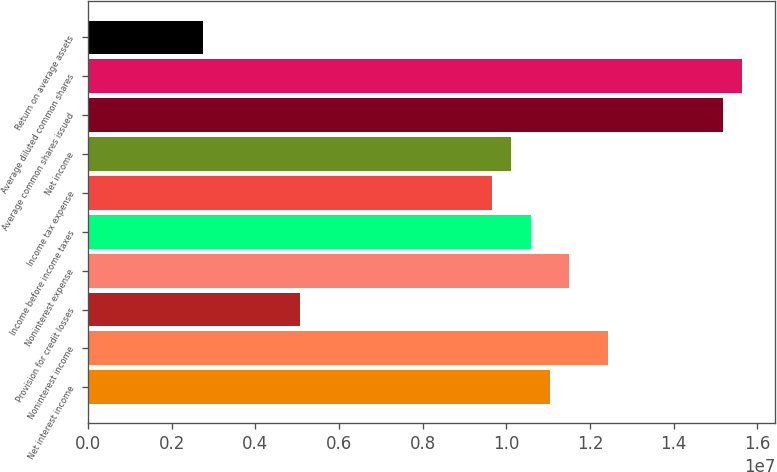Convert chart. <chart><loc_0><loc_0><loc_500><loc_500><bar_chart><fcel>Net interest income<fcel>Noninterest income<fcel>Provision for credit losses<fcel>Noninterest expense<fcel>Income before income taxes<fcel>Income tax expense<fcel>Net income<fcel>Average common shares issued<fcel>Average diluted common shares<fcel>Return on average assets<nl><fcel>1.10428e+07<fcel>1.24232e+07<fcel>5.06129e+06<fcel>1.15029e+07<fcel>1.05827e+07<fcel>9.66245e+06<fcel>1.01226e+07<fcel>1.51839e+07<fcel>1.5644e+07<fcel>2.7607e+06<nl></chart> 